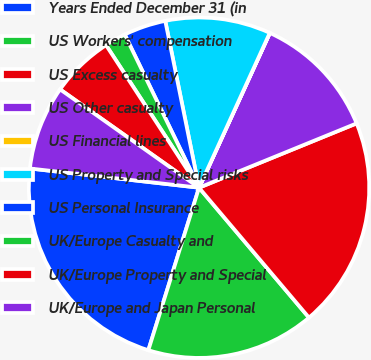<chart> <loc_0><loc_0><loc_500><loc_500><pie_chart><fcel>Years Ended December 31 (in<fcel>US Workers' compensation<fcel>US Excess casualty<fcel>US Other casualty<fcel>US Financial lines<fcel>US Property and Special risks<fcel>US Personal Insurance<fcel>UK/Europe Casualty and<fcel>UK/Europe Property and Special<fcel>UK/Europe and Japan Personal<nl><fcel>21.99%<fcel>15.99%<fcel>19.99%<fcel>12.0%<fcel>0.01%<fcel>10.0%<fcel>4.01%<fcel>2.01%<fcel>6.0%<fcel>8.0%<nl></chart> 